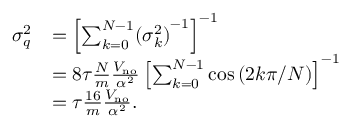Convert formula to latex. <formula><loc_0><loc_0><loc_500><loc_500>\begin{array} { r l } { \sigma _ { q } ^ { 2 } } & { = \left [ \sum _ { k = 0 } ^ { N - 1 } ( { \sigma _ { k } ^ { 2 } ) } ^ { - 1 } \right ] ^ { - 1 } } \\ & { = 8 \tau \frac { N } { m } \frac { V _ { n o } } { \alpha ^ { 2 } } \left [ \sum _ { k = 0 } ^ { N - 1 } \cos \left ( 2 k \pi / N \right ) \right ] ^ { - 1 } } \\ & { = \tau \frac { 1 6 } { m } \frac { V _ { n o } } { \alpha ^ { 2 } } . } \end{array}</formula> 